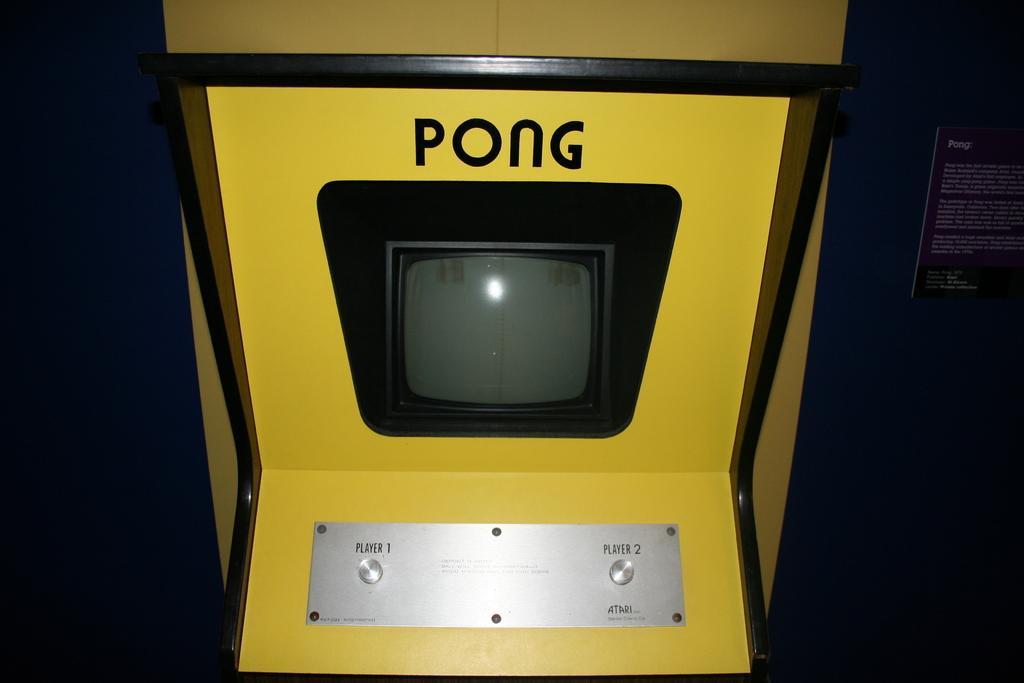Could you give a brief overview of what you see in this image? In the center of this picture we can see a yellow color pong cabinet. In the background we can see a poster attached to the wall and we can see the text on the poster. 